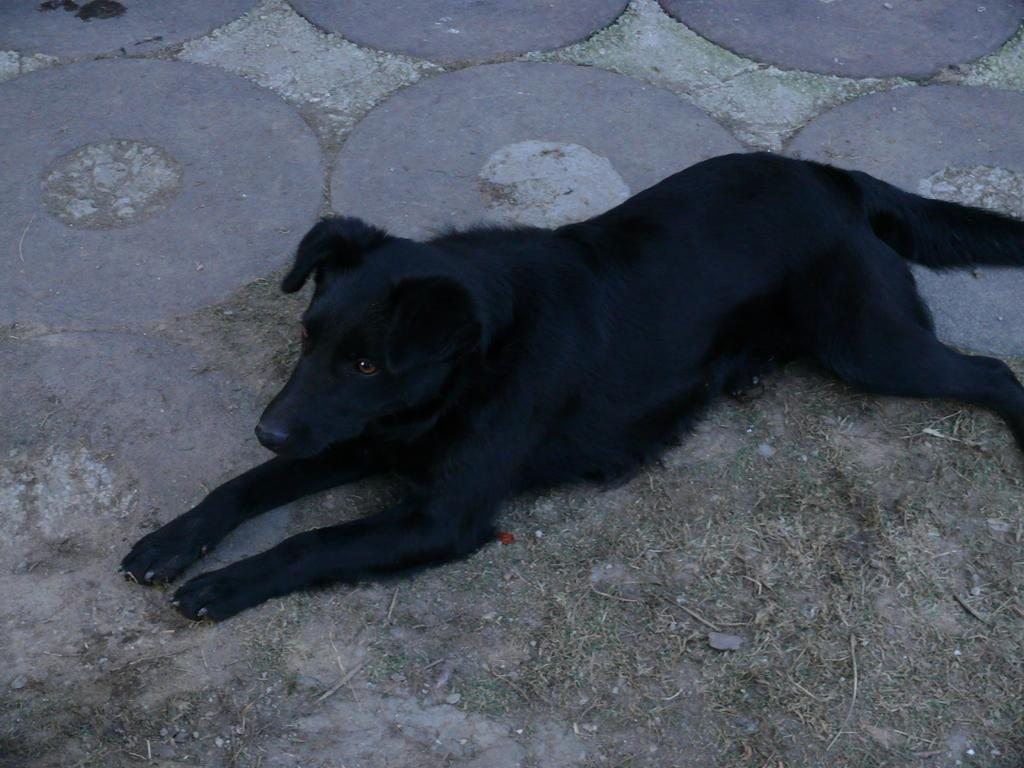What type of animal is in the image? There is a dog in the image. What is the dog doing in the image? The dog is sitting on the ground. What part of the train is visible in the image? There are no trains present in the image; it features a dog sitting on the ground. What decision does the dog make in the image? The image does not depict the dog making a decision; it simply shows the dog sitting on the ground. 